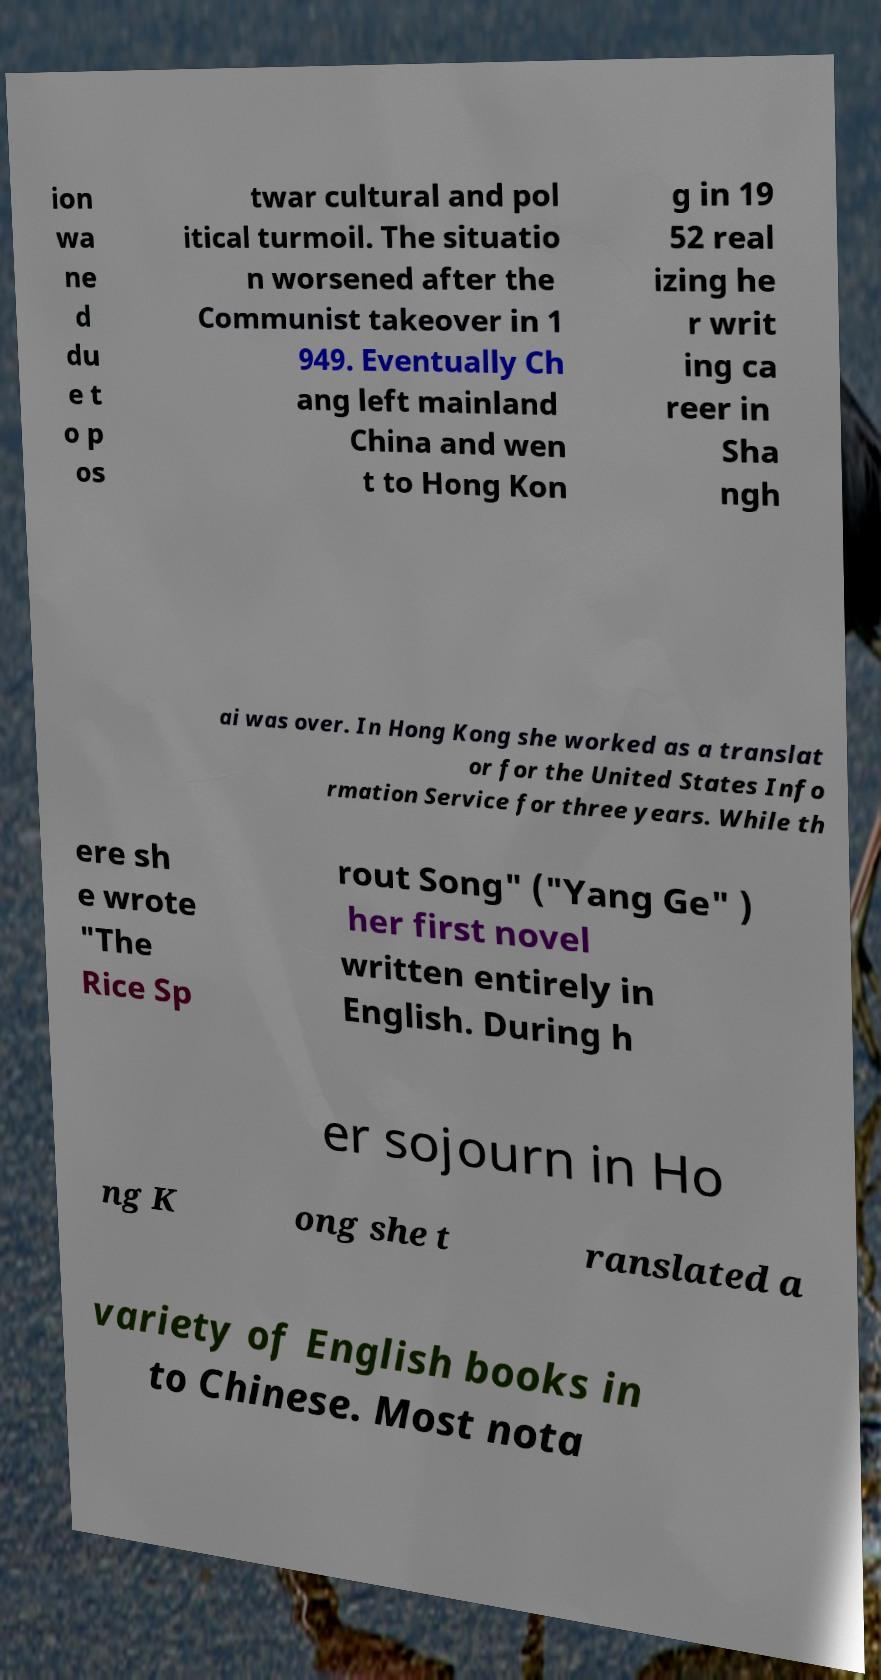I need the written content from this picture converted into text. Can you do that? ion wa ne d du e t o p os twar cultural and pol itical turmoil. The situatio n worsened after the Communist takeover in 1 949. Eventually Ch ang left mainland China and wen t to Hong Kon g in 19 52 real izing he r writ ing ca reer in Sha ngh ai was over. In Hong Kong she worked as a translat or for the United States Info rmation Service for three years. While th ere sh e wrote "The Rice Sp rout Song" ("Yang Ge" ) her first novel written entirely in English. During h er sojourn in Ho ng K ong she t ranslated a variety of English books in to Chinese. Most nota 